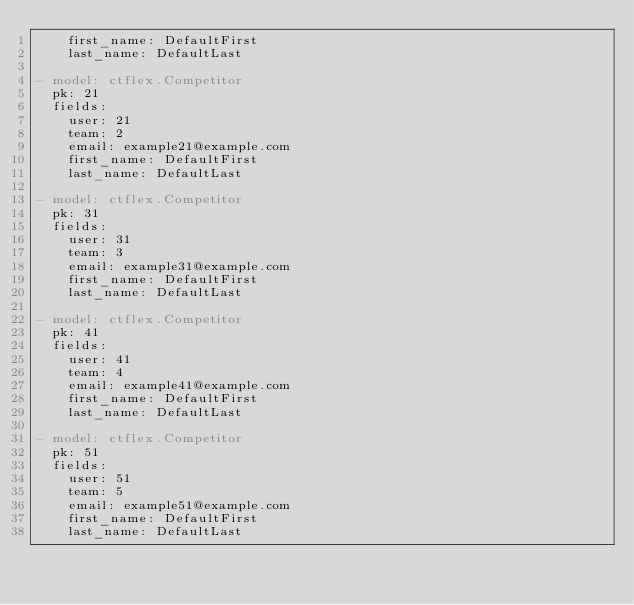Convert code to text. <code><loc_0><loc_0><loc_500><loc_500><_YAML_>    first_name: DefaultFirst
    last_name: DefaultLast

- model: ctflex.Competitor
  pk: 21
  fields:
    user: 21
    team: 2
    email: example21@example.com
    first_name: DefaultFirst
    last_name: DefaultLast

- model: ctflex.Competitor
  pk: 31
  fields:
    user: 31
    team: 3
    email: example31@example.com
    first_name: DefaultFirst
    last_name: DefaultLast

- model: ctflex.Competitor
  pk: 41
  fields:
    user: 41
    team: 4
    email: example41@example.com
    first_name: DefaultFirst
    last_name: DefaultLast

- model: ctflex.Competitor
  pk: 51
  fields:
    user: 51
    team: 5
    email: example51@example.com
    first_name: DefaultFirst
    last_name: DefaultLast
</code> 